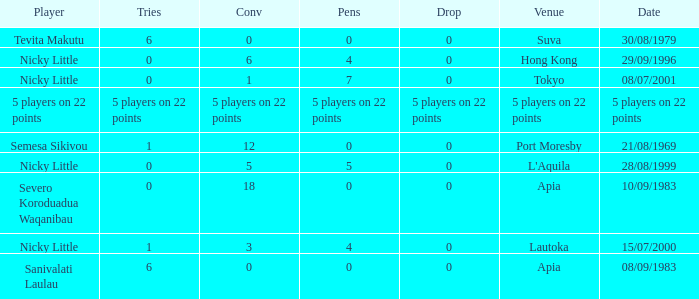How many conversions did Severo Koroduadua Waqanibau have when he has 0 pens? 18.0. 